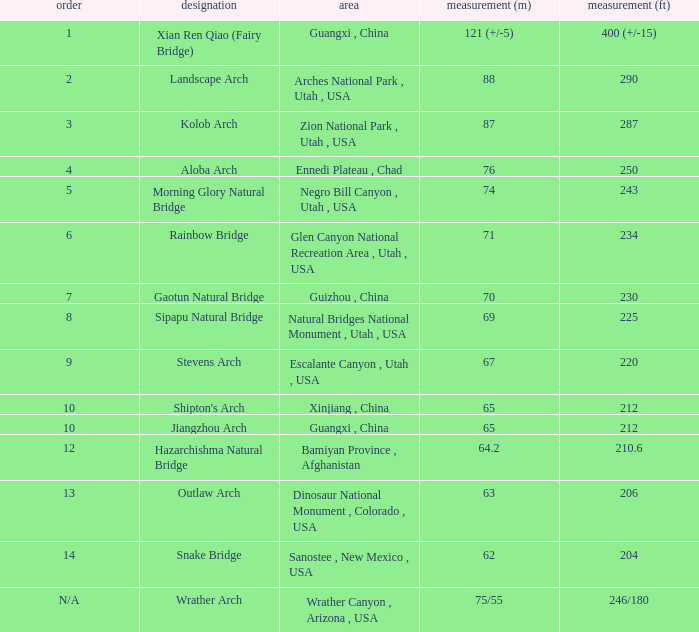What is the length in feet when the length in meters is 64.2? 210.6. 